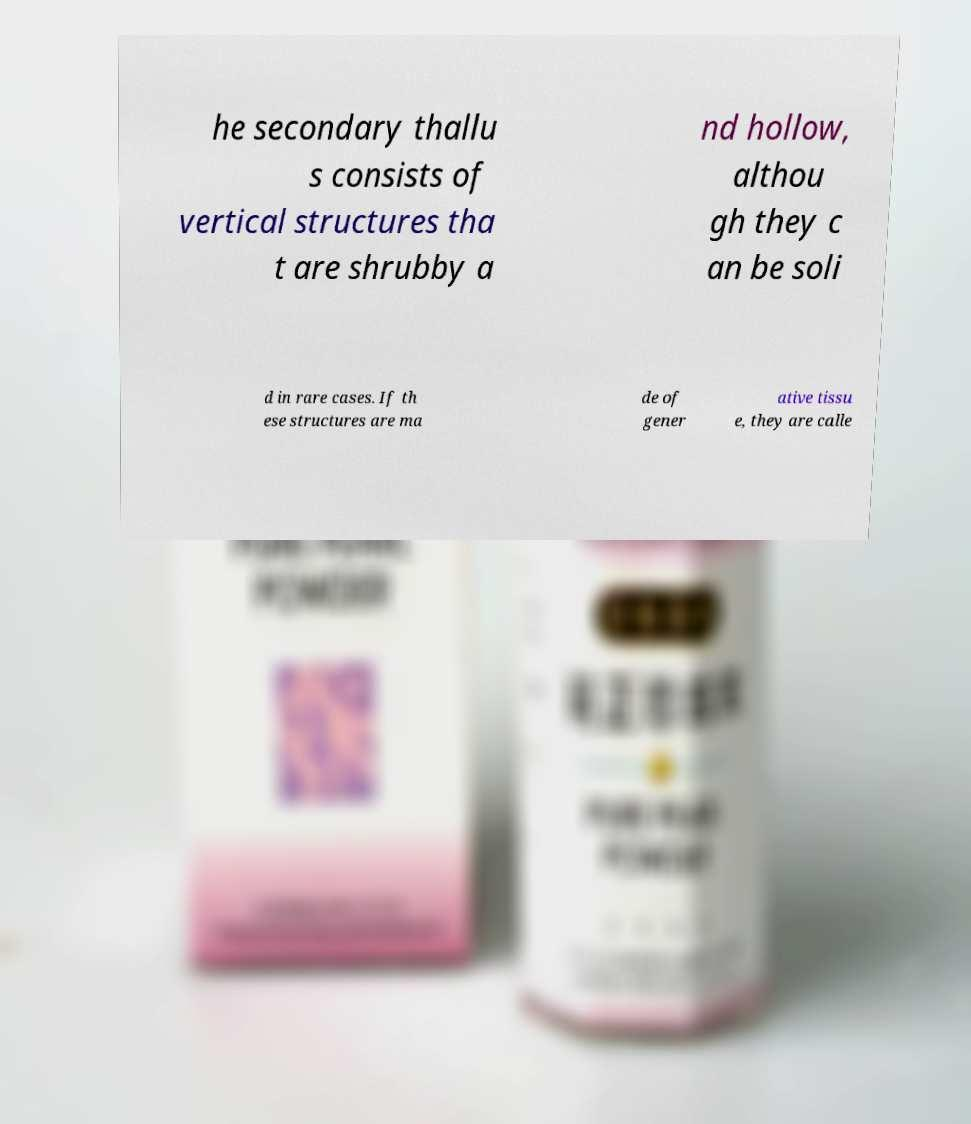There's text embedded in this image that I need extracted. Can you transcribe it verbatim? he secondary thallu s consists of vertical structures tha t are shrubby a nd hollow, althou gh they c an be soli d in rare cases. If th ese structures are ma de of gener ative tissu e, they are calle 